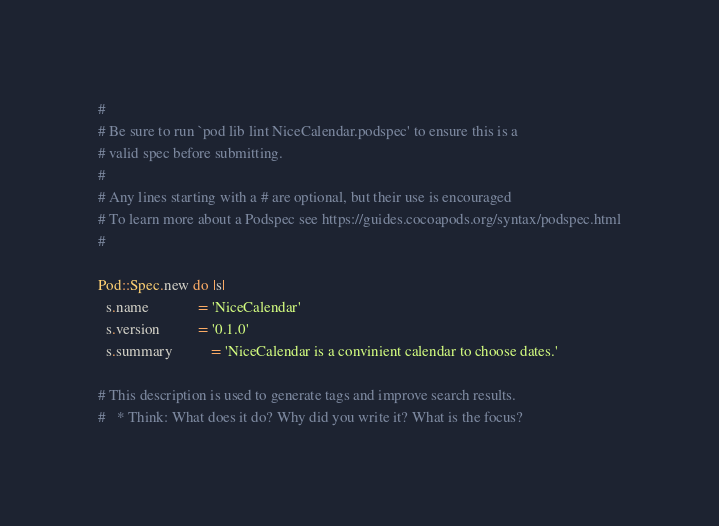<code> <loc_0><loc_0><loc_500><loc_500><_Ruby_>#
# Be sure to run `pod lib lint NiceCalendar.podspec' to ensure this is a
# valid spec before submitting.
#
# Any lines starting with a # are optional, but their use is encouraged
# To learn more about a Podspec see https://guides.cocoapods.org/syntax/podspec.html
#

Pod::Spec.new do |s|
  s.name             = 'NiceCalendar'
  s.version          = '0.1.0'
  s.summary          = 'NiceCalendar is a convinient calendar to choose dates.'

# This description is used to generate tags and improve search results.
#   * Think: What does it do? Why did you write it? What is the focus?</code> 